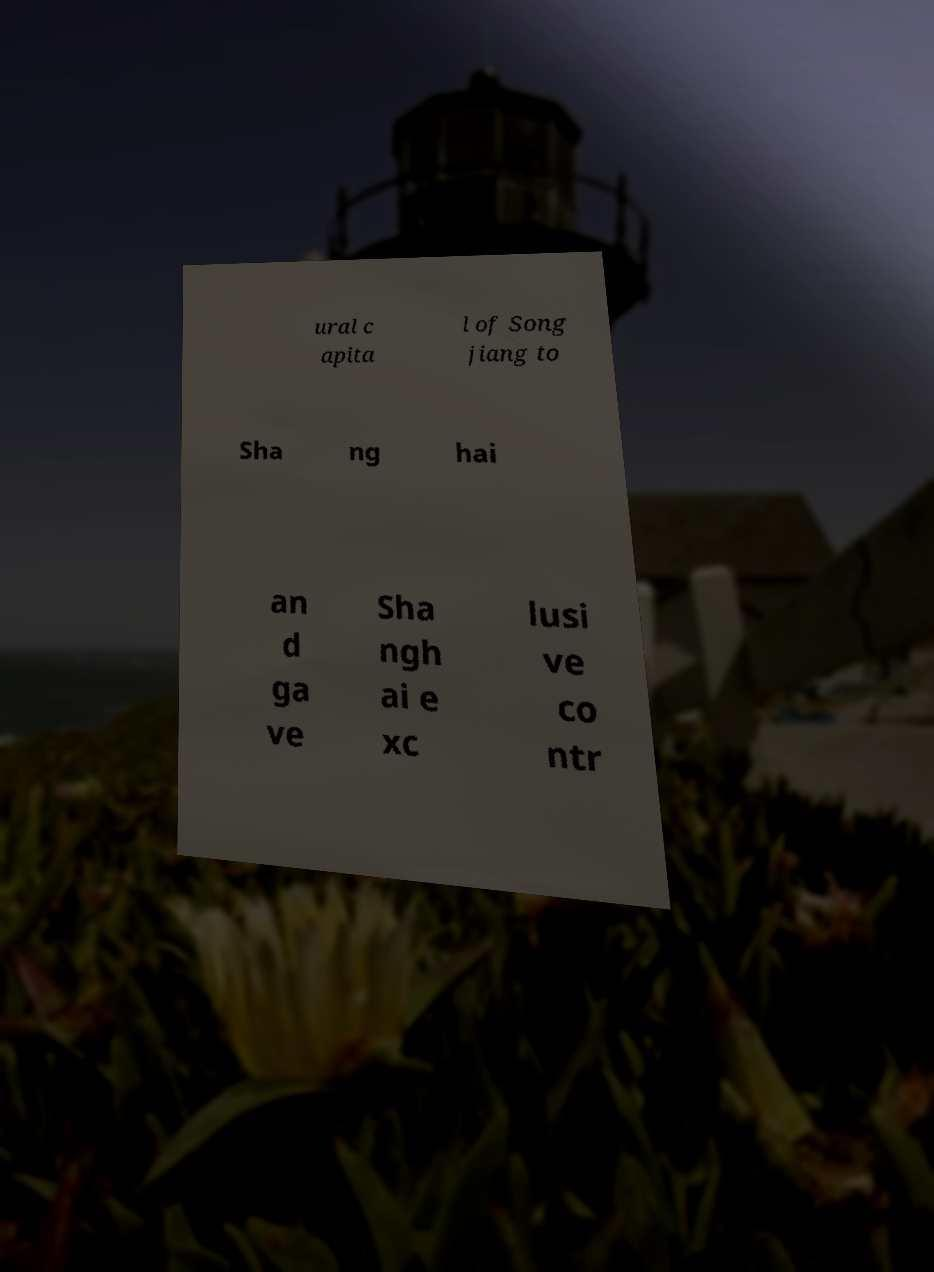Please identify and transcribe the text found in this image. ural c apita l of Song jiang to Sha ng hai an d ga ve Sha ngh ai e xc lusi ve co ntr 